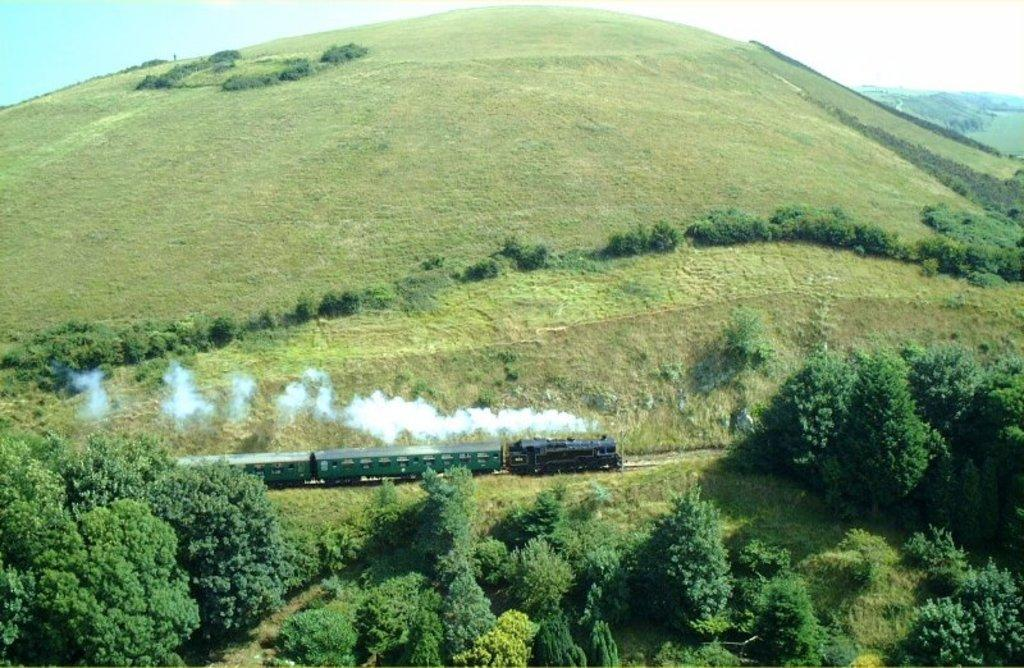What is the main subject of the picture? The main subject of the picture is a train. What is the train doing in the picture? The train is moving in the picture. What type of natural scenery can be seen in the picture? There are trees and mountains in the picture. What is the condition of the sky in the picture? The sky is clear in the picture. Can you tell me how many pieces of advice are given by the cellar in the image? There is no cellar present in the image, and therefore no advice can be given. What type of trail can be seen in the image? There is no trail visible in the image; it features a moving train, trees, mountains, and a clear sky. 